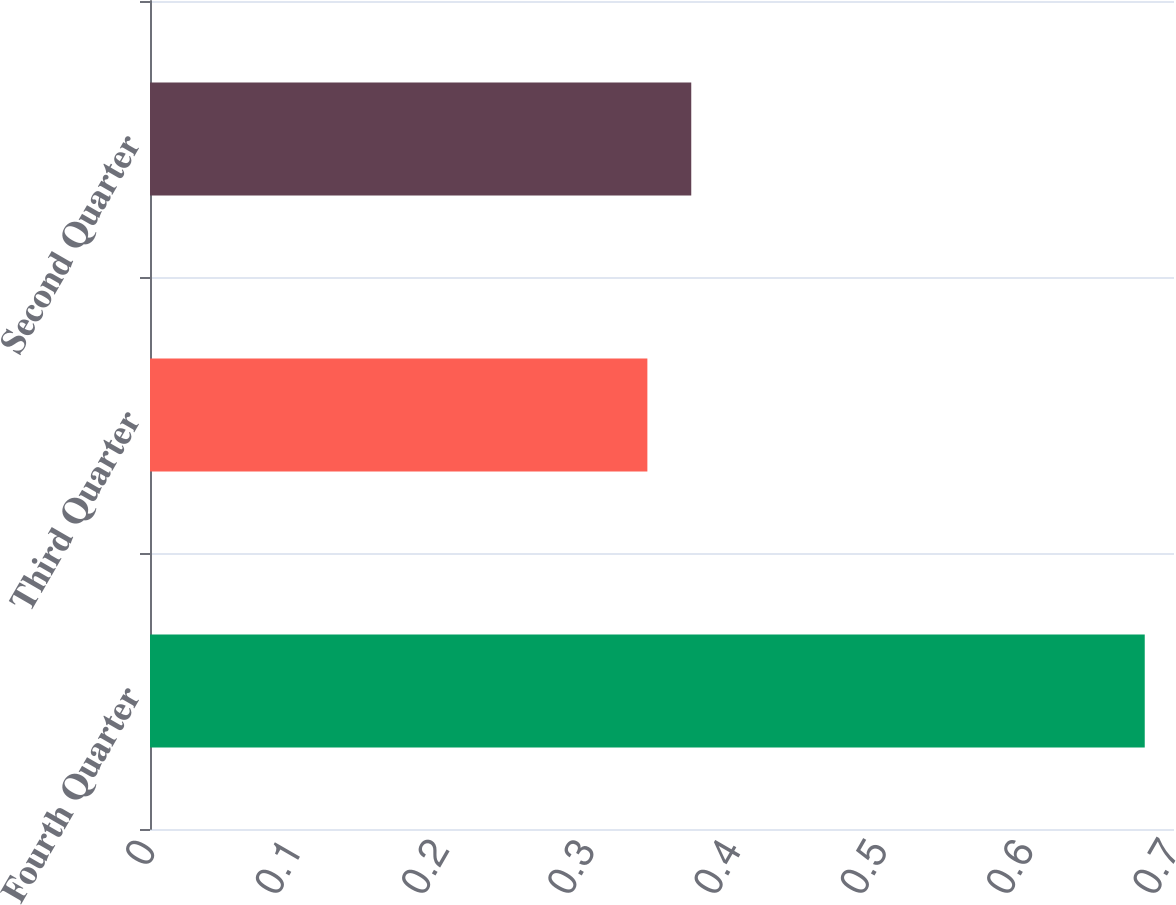Convert chart to OTSL. <chart><loc_0><loc_0><loc_500><loc_500><bar_chart><fcel>Fourth Quarter<fcel>Third Quarter<fcel>Second Quarter<nl><fcel>0.68<fcel>0.34<fcel>0.37<nl></chart> 